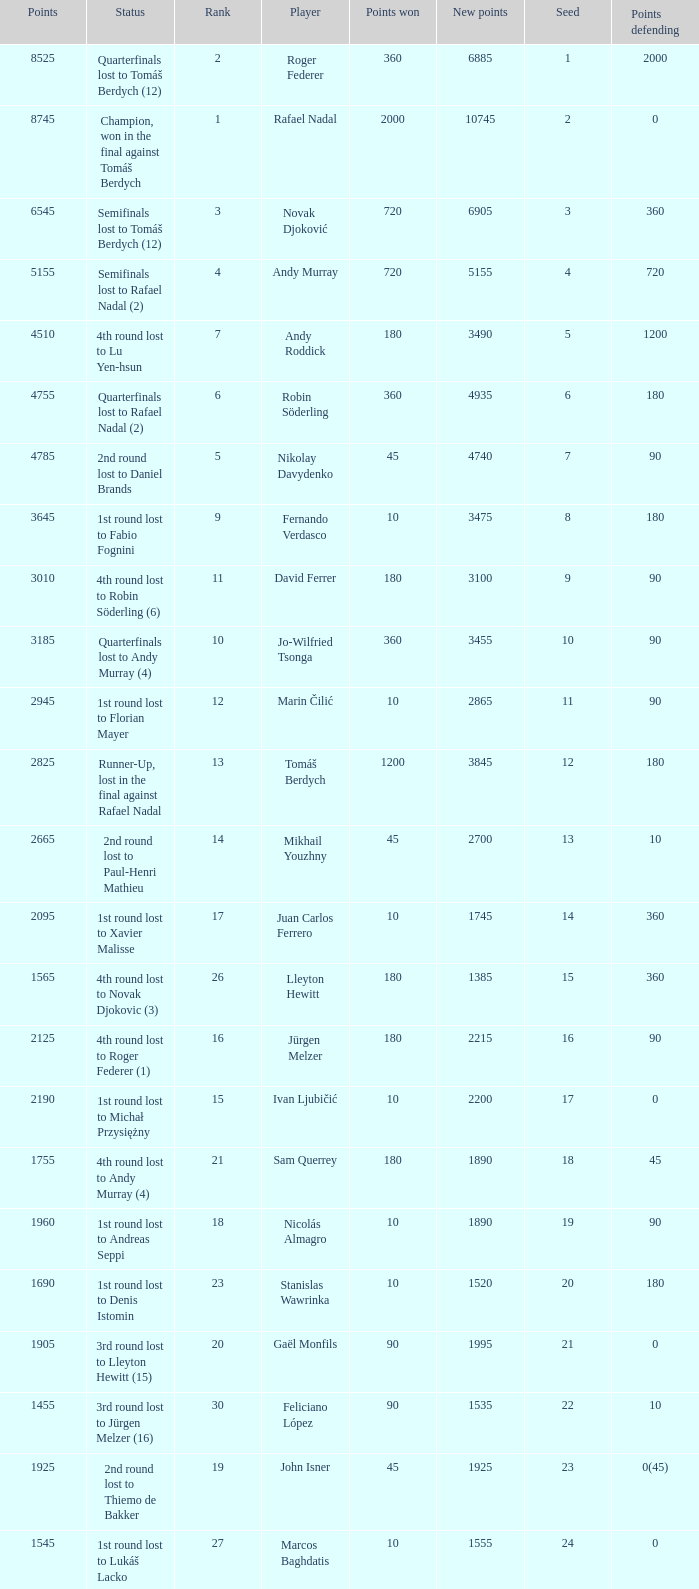Name the number of points defending for 1075 1.0. Give me the full table as a dictionary. {'header': ['Points', 'Status', 'Rank', 'Player', 'Points won', 'New points', 'Seed', 'Points defending'], 'rows': [['8525', 'Quarterfinals lost to Tomáš Berdych (12)', '2', 'Roger Federer', '360', '6885', '1', '2000'], ['8745', 'Champion, won in the final against Tomáš Berdych', '1', 'Rafael Nadal', '2000', '10745', '2', '0'], ['6545', 'Semifinals lost to Tomáš Berdych (12)', '3', 'Novak Djoković', '720', '6905', '3', '360'], ['5155', 'Semifinals lost to Rafael Nadal (2)', '4', 'Andy Murray', '720', '5155', '4', '720'], ['4510', '4th round lost to Lu Yen-hsun', '7', 'Andy Roddick', '180', '3490', '5', '1200'], ['4755', 'Quarterfinals lost to Rafael Nadal (2)', '6', 'Robin Söderling', '360', '4935', '6', '180'], ['4785', '2nd round lost to Daniel Brands', '5', 'Nikolay Davydenko', '45', '4740', '7', '90'], ['3645', '1st round lost to Fabio Fognini', '9', 'Fernando Verdasco', '10', '3475', '8', '180'], ['3010', '4th round lost to Robin Söderling (6)', '11', 'David Ferrer', '180', '3100', '9', '90'], ['3185', 'Quarterfinals lost to Andy Murray (4)', '10', 'Jo-Wilfried Tsonga', '360', '3455', '10', '90'], ['2945', '1st round lost to Florian Mayer', '12', 'Marin Čilić', '10', '2865', '11', '90'], ['2825', 'Runner-Up, lost in the final against Rafael Nadal', '13', 'Tomáš Berdych', '1200', '3845', '12', '180'], ['2665', '2nd round lost to Paul-Henri Mathieu', '14', 'Mikhail Youzhny', '45', '2700', '13', '10'], ['2095', '1st round lost to Xavier Malisse', '17', 'Juan Carlos Ferrero', '10', '1745', '14', '360'], ['1565', '4th round lost to Novak Djokovic (3)', '26', 'Lleyton Hewitt', '180', '1385', '15', '360'], ['2125', '4th round lost to Roger Federer (1)', '16', 'Jürgen Melzer', '180', '2215', '16', '90'], ['2190', '1st round lost to Michał Przysiężny', '15', 'Ivan Ljubičić', '10', '2200', '17', '0'], ['1755', '4th round lost to Andy Murray (4)', '21', 'Sam Querrey', '180', '1890', '18', '45'], ['1960', '1st round lost to Andreas Seppi', '18', 'Nicolás Almagro', '10', '1890', '19', '90'], ['1690', '1st round lost to Denis Istomin', '23', 'Stanislas Wawrinka', '10', '1520', '20', '180'], ['1905', '3rd round lost to Lleyton Hewitt (15)', '20', 'Gaël Monfils', '90', '1995', '21', '0'], ['1455', '3rd round lost to Jürgen Melzer (16)', '30', 'Feliciano López', '90', '1535', '22', '10'], ['1925', '2nd round lost to Thiemo de Bakker', '19', 'John Isner', '45', '1925', '23', '0(45)'], ['1545', '1st round lost to Lukáš Lacko', '27', 'Marcos Baghdatis', '10', '1555', '24', '0'], ['1652', '3rd round lost to Robin Söderling (6)', '24', 'Thomaz Bellucci', '90', '1722', '25', '0(20)'], ['1305', '3rd round lost to Andy Murray (4)', '32', 'Gilles Simon', '90', '1215', '26', '180'], ['1405', '3rd round lost to Novak Djokovic (3)', '31', 'Albert Montañés', '90', '1405', '28', '90'], ['1230', '3rd round lost to Andy Roddick (5)', '35', 'Philipp Kohlschreiber', '90', '1230', '29', '90'], ['1155', '1st round lost to Peter Luczak', '36', 'Tommy Robredo', '10', '1075', '30', '90'], ['1070', '3rd round lost to Daniel Brands', '37', 'Victor Hănescu', '90', '1115', '31', '45'], ['1059', '4th round lost to Jo-Wilfried Tsonga (10)', '38', 'Julien Benneteau', '180', '1229', '32', '10']]} 